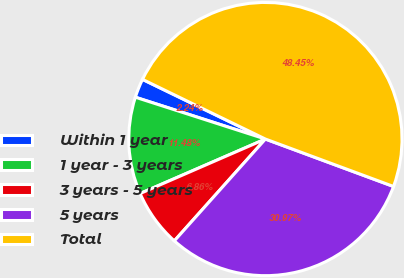<chart> <loc_0><loc_0><loc_500><loc_500><pie_chart><fcel>Within 1 year<fcel>1 year - 3 years<fcel>3 years - 5 years<fcel>5 years<fcel>Total<nl><fcel>2.24%<fcel>11.48%<fcel>6.86%<fcel>30.97%<fcel>48.45%<nl></chart> 